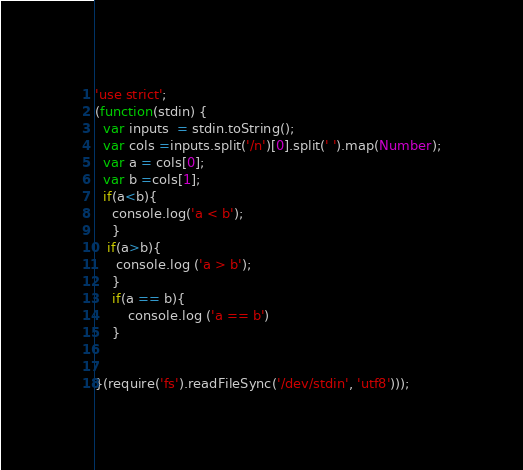Convert code to text. <code><loc_0><loc_0><loc_500><loc_500><_JavaScript_>'use strict';
(function(stdin) {
  var inputs  = stdin.toString();
  var cols =inputs.split('/n')[0].split(' ').map(Number);
  var a = cols[0];
  var b =cols[1];
  if(a<b){
    console.log('a < b');
    }
   if(a>b){
     console.log ('a > b');
    }  
    if(a == b){
        console.log ('a == b')   
    }
  
 
}(require('fs').readFileSync('/dev/stdin', 'utf8')));</code> 